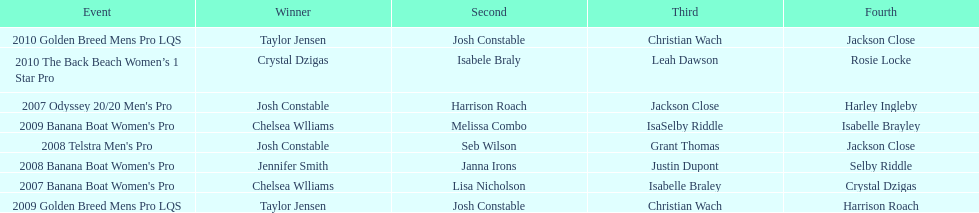How many times was josh constable second? 2. 